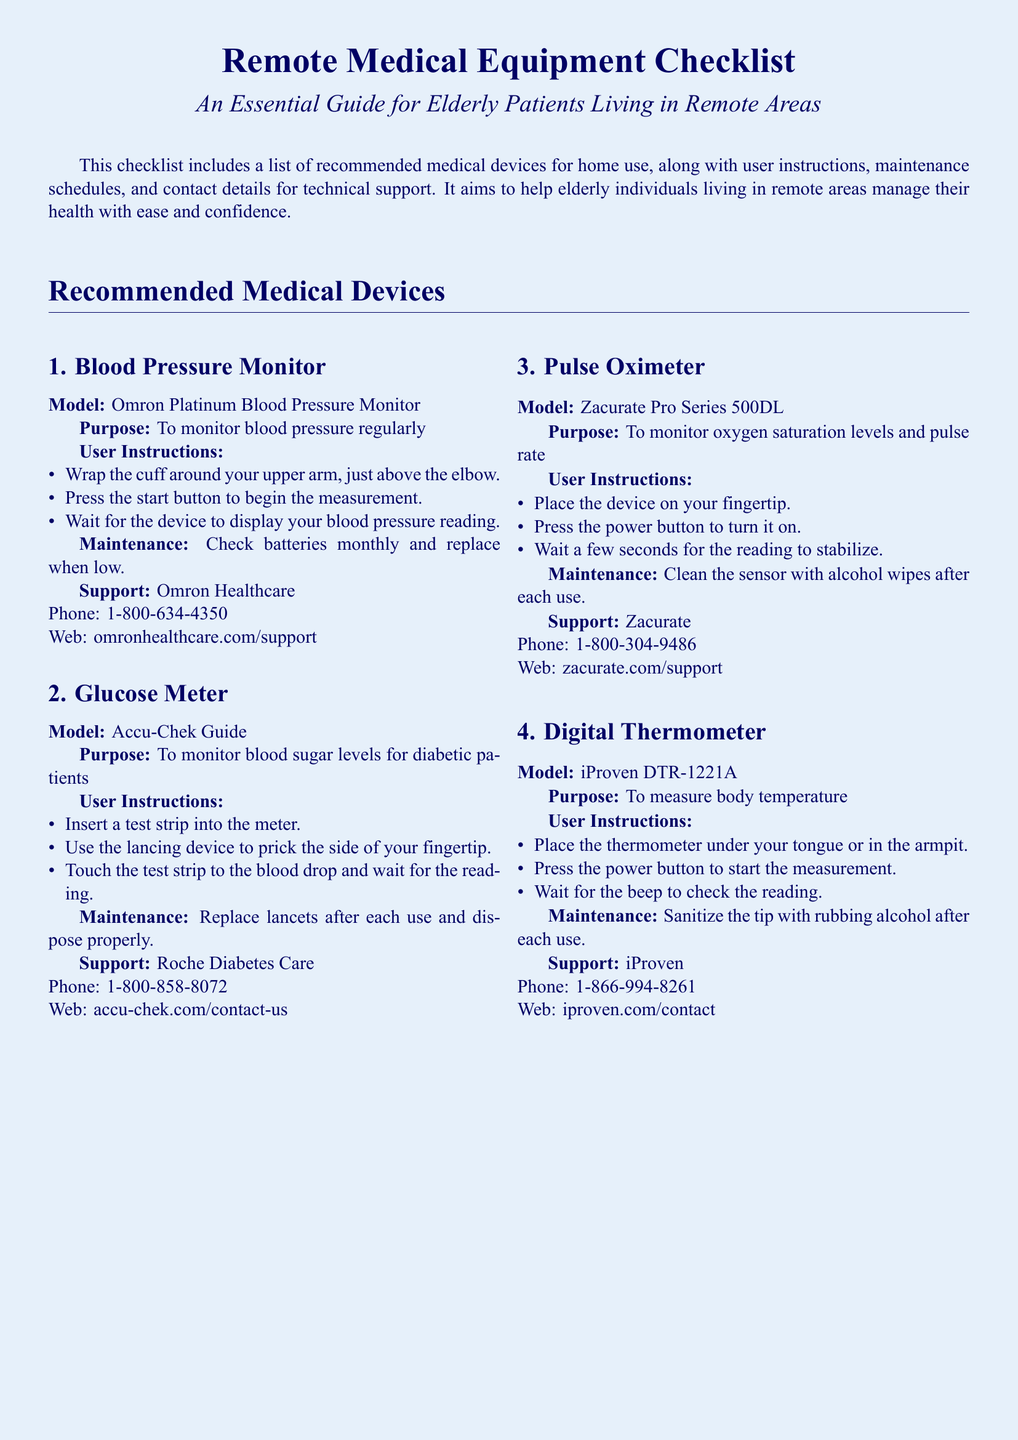What is the model of the blood pressure monitor? The model of the blood pressure monitor is mentioned in the document as "Omron Platinum Blood Pressure Monitor."
Answer: Omron Platinum Blood Pressure Monitor What is the purpose of the glucose meter? The purpose of the glucose meter is specifically stated in the document as "to monitor blood sugar levels for diabetic patients."
Answer: To monitor blood sugar levels for diabetic patients What should be done with the lancets after each use? The maintenance section specifies that "replace lancets after each use and dispose properly."
Answer: Replace lancets after each use and dispose properly How often should batteries be checked for the blood pressure monitor? The maintenance instructions indicate to "check batteries monthly and replace when low."
Answer: Monthly What support contact is provided for the pulse oximeter? The support section for the pulse oximeter includes a phone number, which is stated clearly in the document as "1-800-304-9486."
Answer: 1-800-304-9486 What device is used to monitor oxygen saturation levels? The document states that the pulse oximeter is used for this purpose.
Answer: Pulse Oximeter What type of thermometer is mentioned in the checklist? The model of the thermometer mentioned is "iProven DTR-1221A."
Answer: iProven DTR-1221A What is the user instruction for the digital thermometer? The instruction states to "place the thermometer under your tongue or in the armpit."
Answer: Place the thermometer under your tongue or in the armpit What maintenance is required for the pulse oximeter? The maintenance instructions say to "clean the sensor with alcohol wipes after each use."
Answer: Clean the sensor with alcohol wipes after each use 